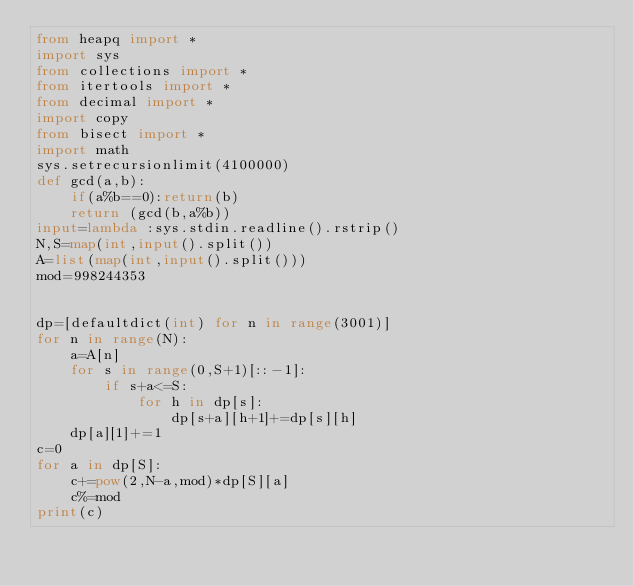Convert code to text. <code><loc_0><loc_0><loc_500><loc_500><_Python_>from heapq import *
import sys
from collections import *
from itertools import *
from decimal import *
import copy
from bisect import *
import math
sys.setrecursionlimit(4100000)
def gcd(a,b):
    if(a%b==0):return(b)
    return (gcd(b,a%b))
input=lambda :sys.stdin.readline().rstrip()
N,S=map(int,input().split())
A=list(map(int,input().split()))
mod=998244353


dp=[defaultdict(int) for n in range(3001)]
for n in range(N):
    a=A[n]
    for s in range(0,S+1)[::-1]:
        if s+a<=S:
            for h in dp[s]:
                dp[s+a][h+1]+=dp[s][h]
    dp[a][1]+=1
c=0
for a in dp[S]:
    c+=pow(2,N-a,mod)*dp[S][a]
    c%=mod
print(c)
</code> 